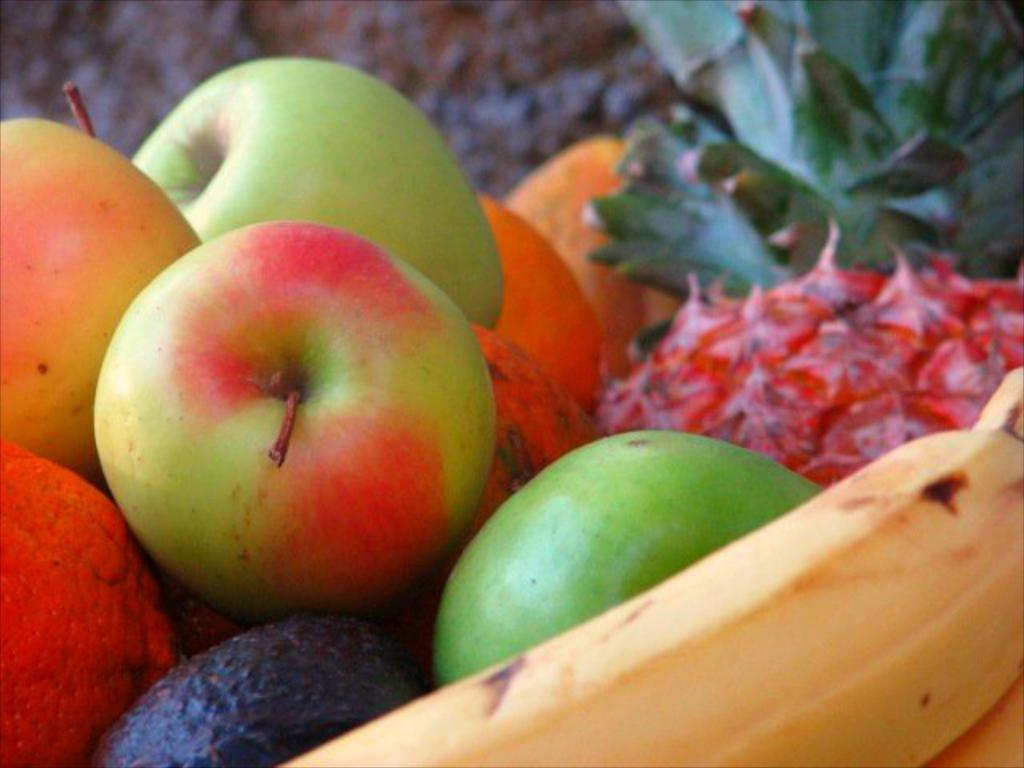What type of fruit is located on the right side of the image? There is a banana on the right side of the image. What type of fruit is located on the left side of the image? There are green apples on the left side of the image. What type of fruit is located in the middle of the image? There is a pineapple in the middle of the image. What type of soda can be seen in the image? There is no soda present in the image; it features fruits only. How many passengers are visible in the image? There are no passengers present in the image; it features fruits only. 